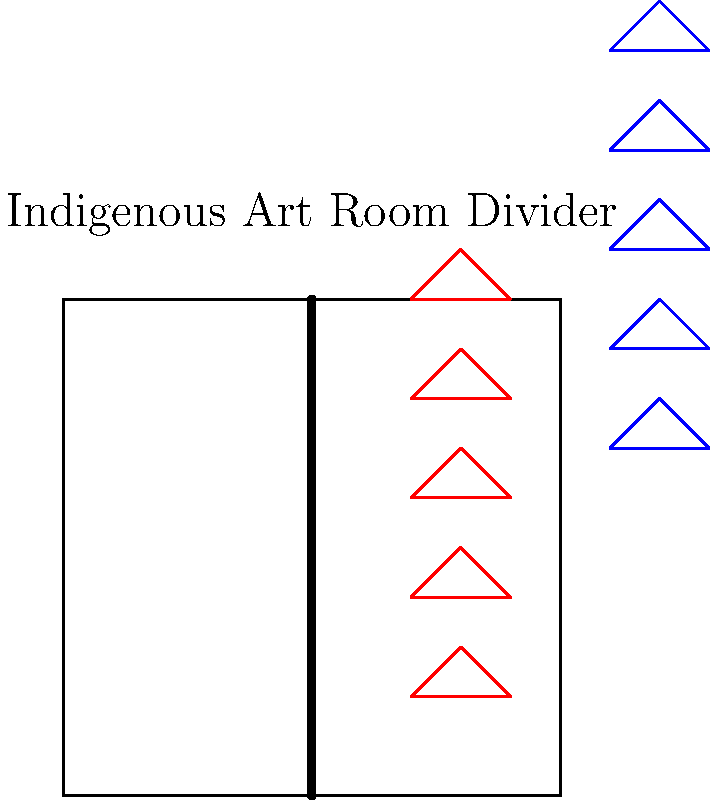In the context of incorporating indigenous art forms into functional interior elements, analyze the room divider design shown in the image. How does this design exemplify the integration of cultural elements, and what considerations should be made when implementing such a feature in a modern interior space? 1. Cultural Integration:
   - The room divider incorporates traditional geometric patterns typical of many indigenous art forms.
   - The repetitive nature of the patterns reflects the rhythmic designs often found in indigenous textiles and pottery.

2. Functionality:
   - The divider serves a practical purpose by separating the space while allowing visual permeability.
   - The open design permits light to pass through, maintaining an airy feel in the room.

3. Color Usage:
   - The use of contrasting colors (red and blue) is reminiscent of bold color choices in many indigenous art traditions.
   - These colors can be customized to match specific cultural references or interior color schemes.

4. Material Considerations:
   - While not specified in the image, the material choice for such a divider is crucial. Traditional materials like wood or modern alternatives like laser-cut metal could be considered.
   - The material should complement both the indigenous design and the modern interior.

5. Scale and Proportion:
   - The size of the patterns relative to the divider is balanced, allowing for visual interest without overwhelming the space.
   - When implementing, consider the room's dimensions to ensure the divider and its patterns are proportionate.

6. Cultural Sensitivity:
   - It's essential to ensure that the use of indigenous patterns is respectful and properly attributed to its cultural origins.
   - Collaboration with indigenous artists or communities can provide authenticity and cultural accuracy.

7. Integration with Modern Elements:
   - The simple, linear nature of the divider allows it to blend with modern interior design while still showcasing cultural elements.
   - Consider how the divider interacts with other design elements in the room, such as furniture and lighting.

8. Versatility:
   - This design concept can be adapted to other functional elements like staircases, wall panels, or even furniture surfaces.

9. Lighting Effects:
   - The open pattern creates opportunities for interesting shadow play when lit, adding depth to the interior design.

10. Maintenance and Durability:
    - The complexity of the pattern may impact cleaning and maintenance. Consider this when choosing materials and finishes.
Answer: Indigenous-inspired geometric patterns on a functional room divider, balancing cultural representation with modern interior design needs. 